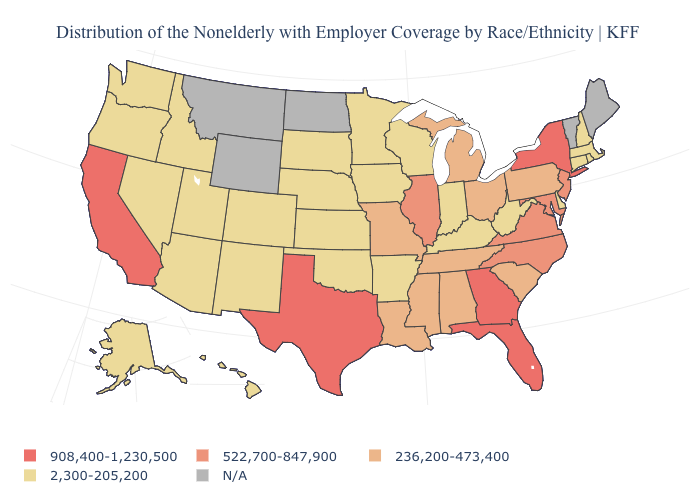What is the value of Wyoming?
Be succinct. N/A. Name the states that have a value in the range 2,300-205,200?
Keep it brief. Alaska, Arizona, Arkansas, Colorado, Connecticut, Delaware, Hawaii, Idaho, Indiana, Iowa, Kansas, Kentucky, Massachusetts, Minnesota, Nebraska, Nevada, New Hampshire, New Mexico, Oklahoma, Oregon, Rhode Island, South Dakota, Utah, Washington, West Virginia, Wisconsin. Which states hav the highest value in the MidWest?
Keep it brief. Illinois. Which states have the lowest value in the USA?
Give a very brief answer. Alaska, Arizona, Arkansas, Colorado, Connecticut, Delaware, Hawaii, Idaho, Indiana, Iowa, Kansas, Kentucky, Massachusetts, Minnesota, Nebraska, Nevada, New Hampshire, New Mexico, Oklahoma, Oregon, Rhode Island, South Dakota, Utah, Washington, West Virginia, Wisconsin. What is the value of Hawaii?
Concise answer only. 2,300-205,200. Does Maryland have the highest value in the USA?
Answer briefly. No. Name the states that have a value in the range 908,400-1,230,500?
Write a very short answer. California, Florida, Georgia, New York, Texas. What is the highest value in the USA?
Quick response, please. 908,400-1,230,500. Does Kansas have the highest value in the USA?
Write a very short answer. No. Which states have the highest value in the USA?
Concise answer only. California, Florida, Georgia, New York, Texas. What is the highest value in states that border Missouri?
Concise answer only. 522,700-847,900. Among the states that border Ohio , does Pennsylvania have the lowest value?
Keep it brief. No. Name the states that have a value in the range 908,400-1,230,500?
Concise answer only. California, Florida, Georgia, New York, Texas. 